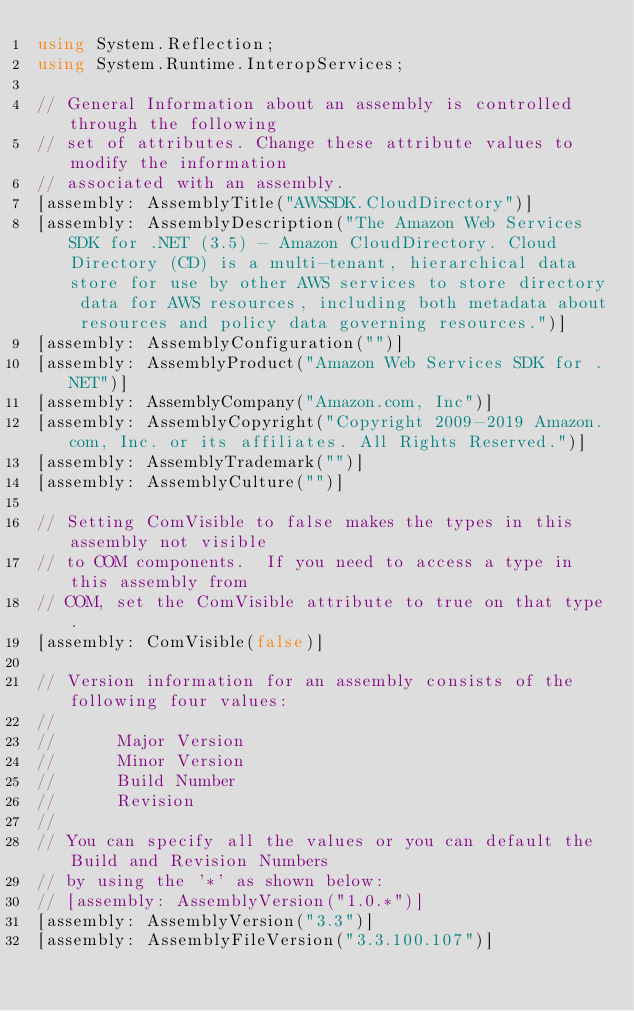Convert code to text. <code><loc_0><loc_0><loc_500><loc_500><_C#_>using System.Reflection;
using System.Runtime.InteropServices;

// General Information about an assembly is controlled through the following 
// set of attributes. Change these attribute values to modify the information
// associated with an assembly.
[assembly: AssemblyTitle("AWSSDK.CloudDirectory")]
[assembly: AssemblyDescription("The Amazon Web Services SDK for .NET (3.5) - Amazon CloudDirectory. Cloud Directory (CD) is a multi-tenant, hierarchical data store for use by other AWS services to store directory data for AWS resources, including both metadata about resources and policy data governing resources.")]
[assembly: AssemblyConfiguration("")]
[assembly: AssemblyProduct("Amazon Web Services SDK for .NET")]
[assembly: AssemblyCompany("Amazon.com, Inc")]
[assembly: AssemblyCopyright("Copyright 2009-2019 Amazon.com, Inc. or its affiliates. All Rights Reserved.")]
[assembly: AssemblyTrademark("")]
[assembly: AssemblyCulture("")]

// Setting ComVisible to false makes the types in this assembly not visible 
// to COM components.  If you need to access a type in this assembly from 
// COM, set the ComVisible attribute to true on that type.
[assembly: ComVisible(false)]

// Version information for an assembly consists of the following four values:
//
//      Major Version
//      Minor Version 
//      Build Number
//      Revision
//
// You can specify all the values or you can default the Build and Revision Numbers 
// by using the '*' as shown below:
// [assembly: AssemblyVersion("1.0.*")]
[assembly: AssemblyVersion("3.3")]
[assembly: AssemblyFileVersion("3.3.100.107")]</code> 